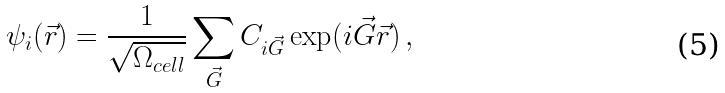Convert formula to latex. <formula><loc_0><loc_0><loc_500><loc_500>\psi _ { i } ( \vec { r } ) = \frac { 1 } { \sqrt { \Omega _ { c e l l } } } \sum _ { \vec { G } } C _ { i \vec { G } } \exp ( i \vec { G } \vec { r } ) \, ,</formula> 